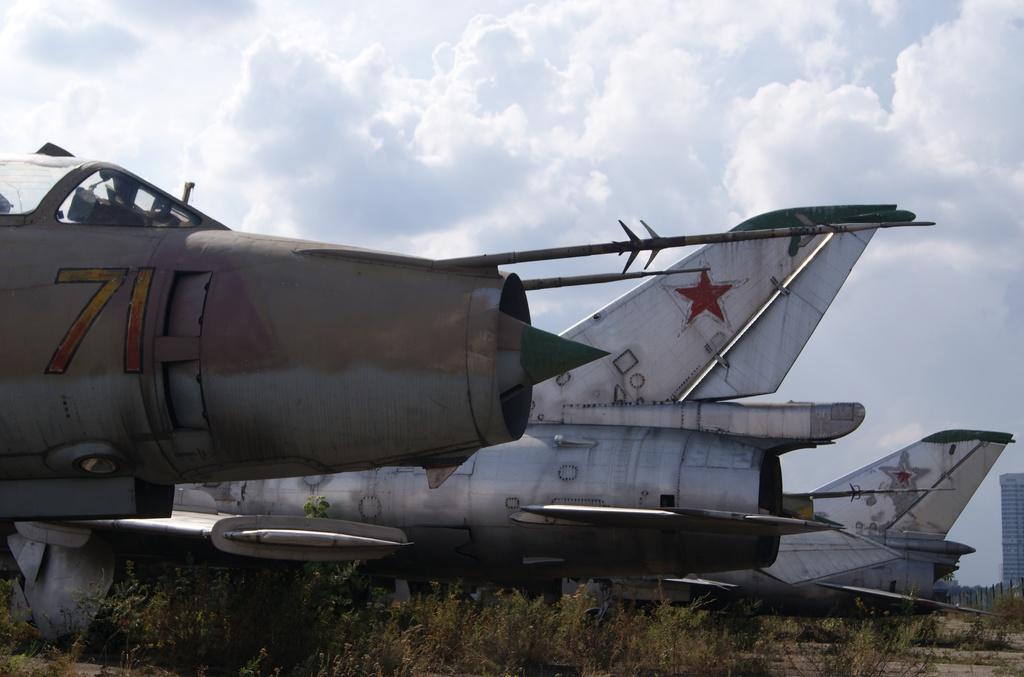What number is on the first plane?
Provide a succinct answer. 71. 